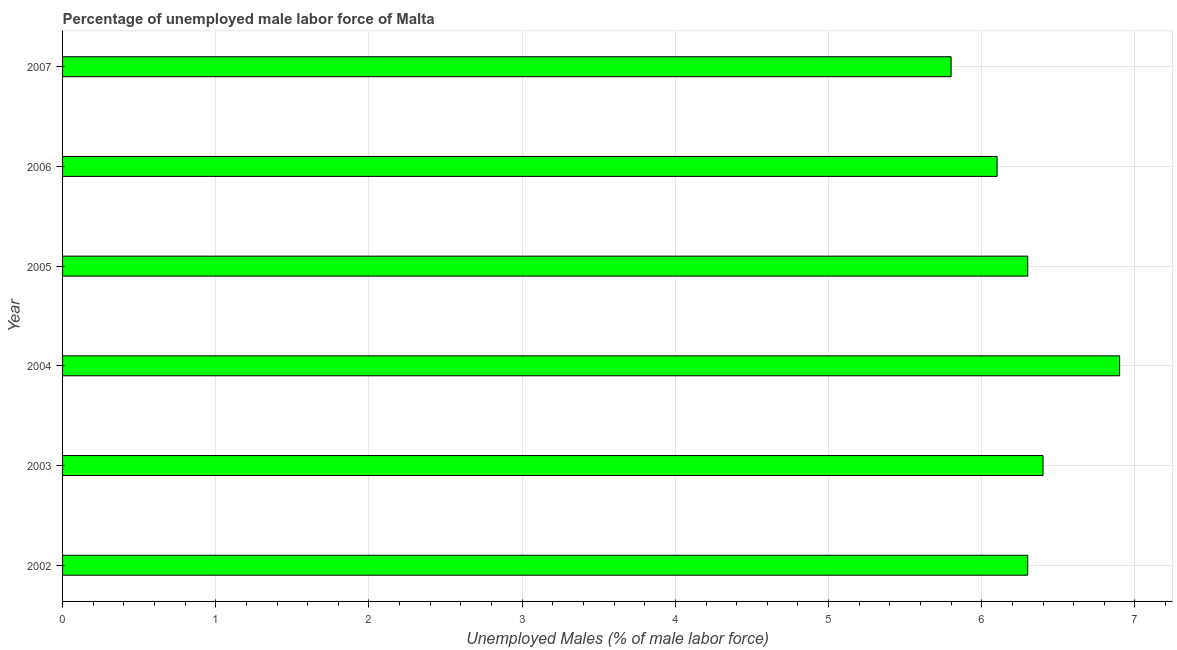Does the graph contain grids?
Give a very brief answer. Yes. What is the title of the graph?
Your answer should be compact. Percentage of unemployed male labor force of Malta. What is the label or title of the X-axis?
Your answer should be compact. Unemployed Males (% of male labor force). What is the label or title of the Y-axis?
Your answer should be compact. Year. What is the total unemployed male labour force in 2005?
Your answer should be compact. 6.3. Across all years, what is the maximum total unemployed male labour force?
Offer a very short reply. 6.9. Across all years, what is the minimum total unemployed male labour force?
Your answer should be compact. 5.8. In which year was the total unemployed male labour force maximum?
Ensure brevity in your answer.  2004. In which year was the total unemployed male labour force minimum?
Provide a short and direct response. 2007. What is the sum of the total unemployed male labour force?
Offer a terse response. 37.8. What is the difference between the total unemployed male labour force in 2003 and 2004?
Give a very brief answer. -0.5. What is the average total unemployed male labour force per year?
Your answer should be compact. 6.3. What is the median total unemployed male labour force?
Offer a very short reply. 6.3. Is the sum of the total unemployed male labour force in 2006 and 2007 greater than the maximum total unemployed male labour force across all years?
Make the answer very short. Yes. Are all the bars in the graph horizontal?
Offer a very short reply. Yes. How many years are there in the graph?
Offer a very short reply. 6. What is the difference between two consecutive major ticks on the X-axis?
Give a very brief answer. 1. What is the Unemployed Males (% of male labor force) of 2002?
Provide a succinct answer. 6.3. What is the Unemployed Males (% of male labor force) of 2003?
Ensure brevity in your answer.  6.4. What is the Unemployed Males (% of male labor force) of 2004?
Provide a short and direct response. 6.9. What is the Unemployed Males (% of male labor force) of 2005?
Your response must be concise. 6.3. What is the Unemployed Males (% of male labor force) of 2006?
Your answer should be very brief. 6.1. What is the Unemployed Males (% of male labor force) in 2007?
Offer a terse response. 5.8. What is the difference between the Unemployed Males (% of male labor force) in 2002 and 2003?
Your response must be concise. -0.1. What is the difference between the Unemployed Males (% of male labor force) in 2002 and 2004?
Ensure brevity in your answer.  -0.6. What is the difference between the Unemployed Males (% of male labor force) in 2002 and 2005?
Offer a terse response. 0. What is the difference between the Unemployed Males (% of male labor force) in 2002 and 2006?
Your answer should be very brief. 0.2. What is the difference between the Unemployed Males (% of male labor force) in 2002 and 2007?
Offer a terse response. 0.5. What is the difference between the Unemployed Males (% of male labor force) in 2003 and 2004?
Offer a terse response. -0.5. What is the difference between the Unemployed Males (% of male labor force) in 2005 and 2006?
Your answer should be very brief. 0.2. What is the difference between the Unemployed Males (% of male labor force) in 2005 and 2007?
Provide a short and direct response. 0.5. What is the difference between the Unemployed Males (% of male labor force) in 2006 and 2007?
Offer a terse response. 0.3. What is the ratio of the Unemployed Males (% of male labor force) in 2002 to that in 2005?
Keep it short and to the point. 1. What is the ratio of the Unemployed Males (% of male labor force) in 2002 to that in 2006?
Offer a very short reply. 1.03. What is the ratio of the Unemployed Males (% of male labor force) in 2002 to that in 2007?
Give a very brief answer. 1.09. What is the ratio of the Unemployed Males (% of male labor force) in 2003 to that in 2004?
Offer a terse response. 0.93. What is the ratio of the Unemployed Males (% of male labor force) in 2003 to that in 2006?
Give a very brief answer. 1.05. What is the ratio of the Unemployed Males (% of male labor force) in 2003 to that in 2007?
Offer a very short reply. 1.1. What is the ratio of the Unemployed Males (% of male labor force) in 2004 to that in 2005?
Keep it short and to the point. 1.09. What is the ratio of the Unemployed Males (% of male labor force) in 2004 to that in 2006?
Offer a terse response. 1.13. What is the ratio of the Unemployed Males (% of male labor force) in 2004 to that in 2007?
Ensure brevity in your answer.  1.19. What is the ratio of the Unemployed Males (% of male labor force) in 2005 to that in 2006?
Keep it short and to the point. 1.03. What is the ratio of the Unemployed Males (% of male labor force) in 2005 to that in 2007?
Ensure brevity in your answer.  1.09. What is the ratio of the Unemployed Males (% of male labor force) in 2006 to that in 2007?
Your answer should be compact. 1.05. 